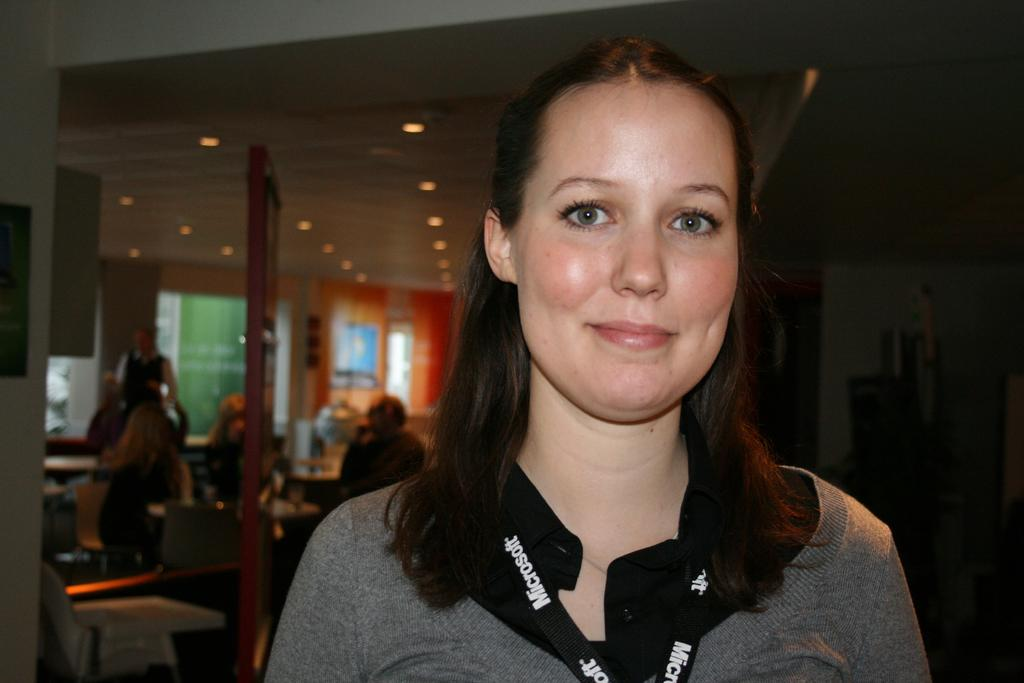Provide a one-sentence caption for the provided image. A woman is wearing a Microsoft lanyard and smiling. 